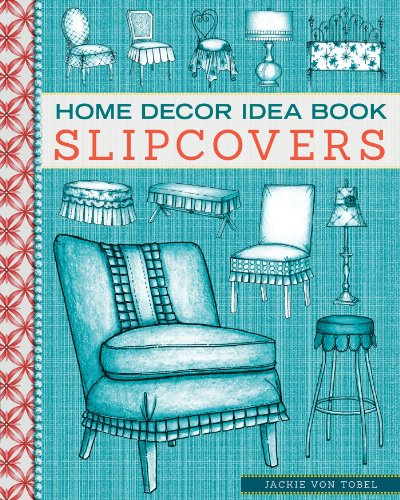Is this book related to Crafts, Hobbies & Home? Yes, this book is indeed related to the 'Crafts, Hobbies & Home' category, providing a wealth of creative ideas for personalizing living spaces through upholstery and other fabric-related crafts. 